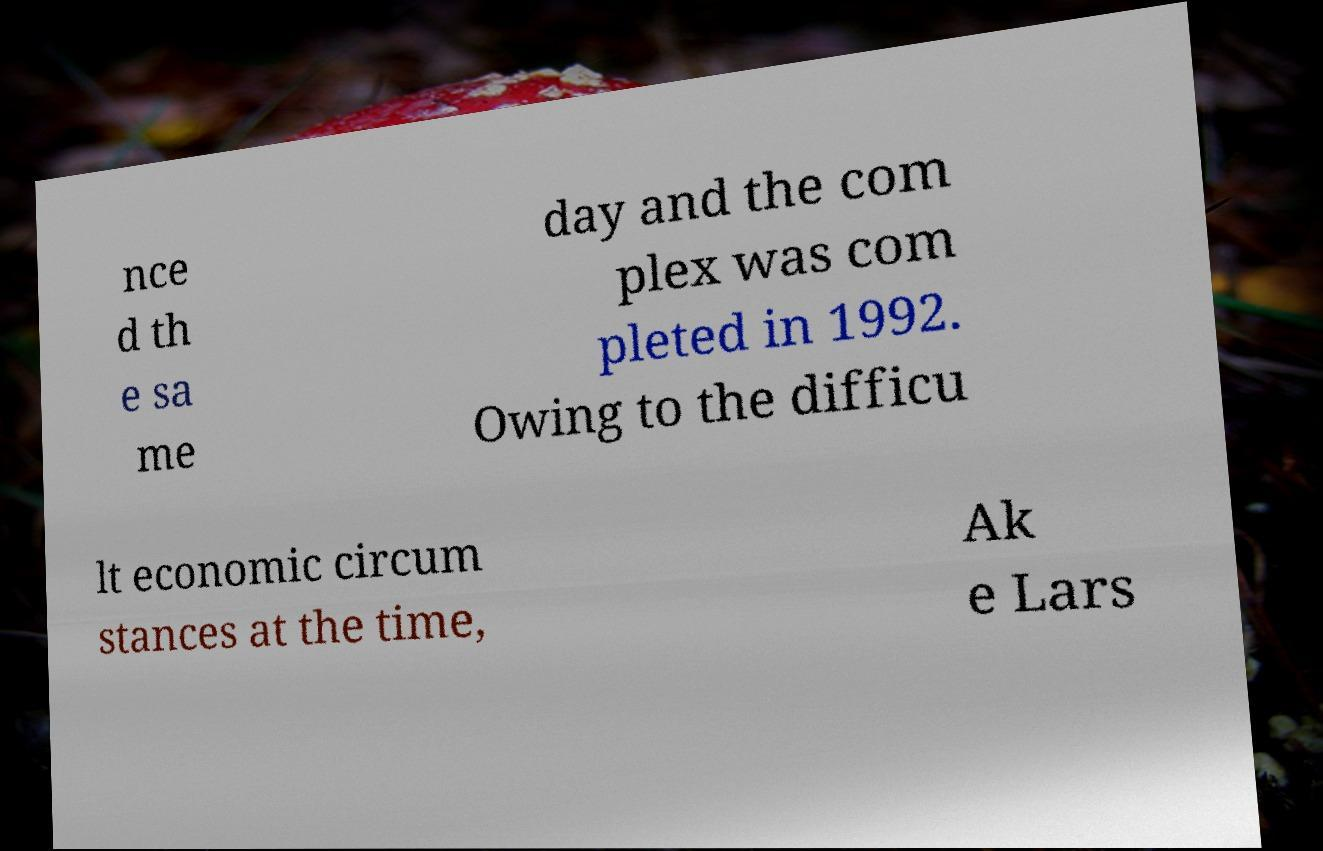What messages or text are displayed in this image? I need them in a readable, typed format. nce d th e sa me day and the com plex was com pleted in 1992. Owing to the difficu lt economic circum stances at the time, Ak e Lars 